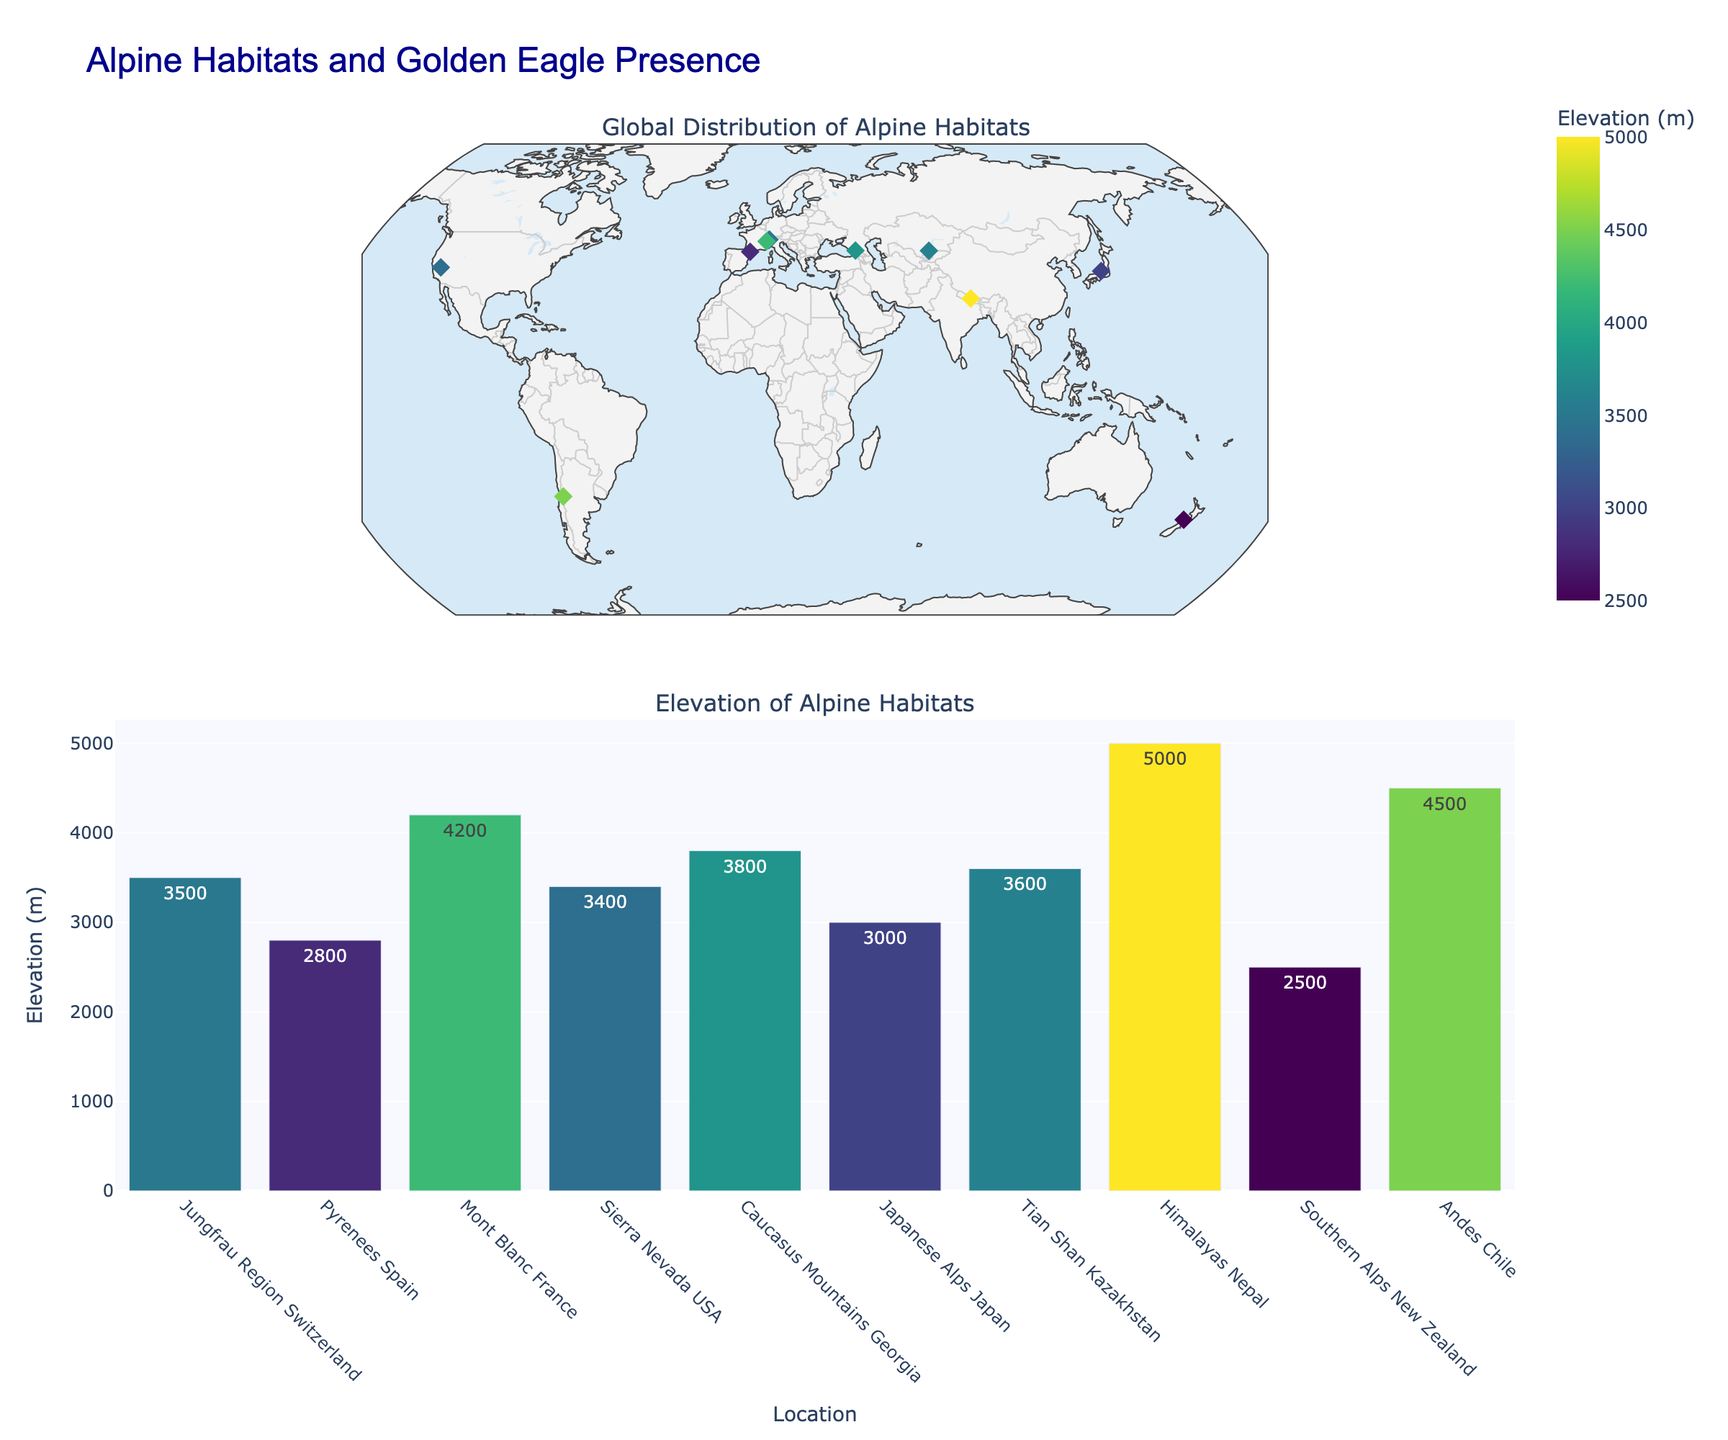What is the title of the plot? The title of the plot is generally found at the top center, summarizing the main focus of the visual information.
Answer: Alpine Habitats and Golden Eagle Presence How many locations have a "Common" presence of golden eagles? By reading the text annotations in the scatter plot, identify the locations labeled with "Golden Eagle: Common," and count these locations.
Answer: Four locations Which location has the highest elevation? Look at the bar chart in the second plot, find the bar with the maximum height, and read the corresponding location label. Alternatively, check the color scale on the scatter plot for the darkest marker.
Answer: Himalayas Nepal What is the average elevation of the locations shown in the plot? Sum up all the elevation values from each location and divide by the number of locations. (3500 + 2800 + 4200 + 3400 + 3800 + 3000 + 3600 + 5000 + 2500 + 4500) / 10 = 36300 / 10 = 3630
Answer: 3630 meters Which alpine habitat type is the most common among the locations? Inspect the text annotations in the scatter plot, identify the most frequently mentioned habitat type, and count their occurrences.
Answer: Alpine Tundra and Alpine Grassland (both mentioned twice) Which two locations are geographically closest to each other? Visually inspect the scatter plot on the world map, find the two markers that are nearest to each other, and identify their location labels.
Answer: Jungfrau Region Switzerland and Mont Blanc France How does the elevation of the Andes Chile compare to that of the Sierra Nevada USA? In the bar chart or the scatter plot, find the elevations for both locations and compare them. Andes Chile has an elevation of 4500 meters, and Sierra Nevada USA has 3400 meters.
Answer: Andes Chile is higher Which location has a "Rare" presence of golden eagles and the lowest elevation? From the scatter plot annotations, identify locations with "Rare" golden eagle presence, then check their elevations and find the smallest value.
Answer: Southern Alps New Zealand What is the range of elevations among the locations? Subtract the smallest elevation value from the largest elevation value among the given data points. The highest elevation is 5000 meters (Himalayas Nepal), and the lowest is 2500 meters (Southern Alps New Zealand).
Answer: 5000 - 2500 = 2500 meters 